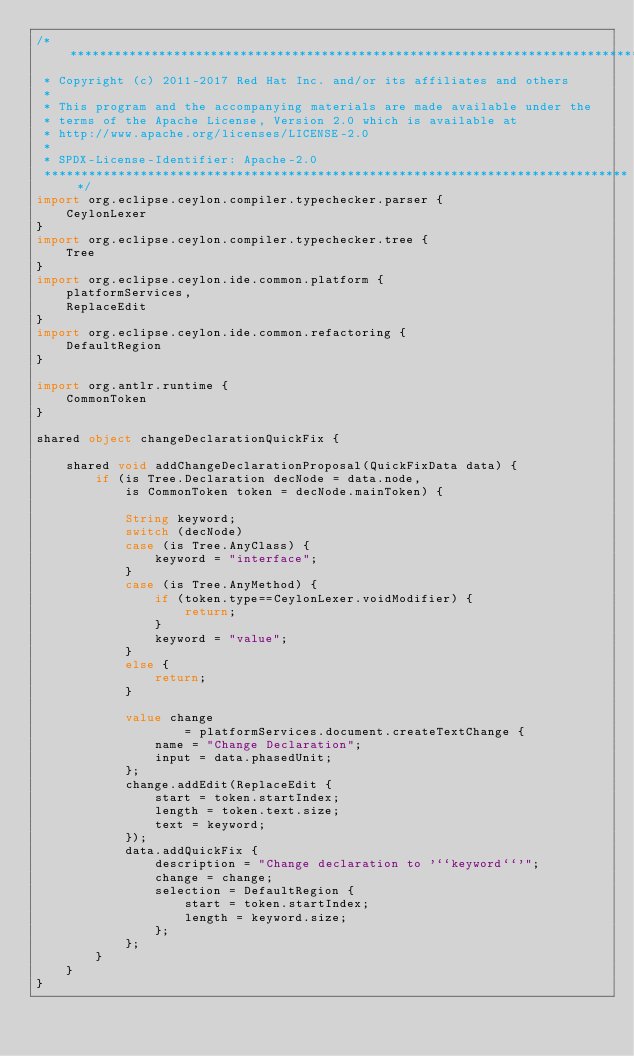Convert code to text. <code><loc_0><loc_0><loc_500><loc_500><_Ceylon_>/********************************************************************************
 * Copyright (c) 2011-2017 Red Hat Inc. and/or its affiliates and others
 *
 * This program and the accompanying materials are made available under the 
 * terms of the Apache License, Version 2.0 which is available at
 * http://www.apache.org/licenses/LICENSE-2.0
 *
 * SPDX-License-Identifier: Apache-2.0 
 ********************************************************************************/
import org.eclipse.ceylon.compiler.typechecker.parser {
    CeylonLexer
}
import org.eclipse.ceylon.compiler.typechecker.tree {
    Tree
}
import org.eclipse.ceylon.ide.common.platform {
    platformServices,
    ReplaceEdit
}
import org.eclipse.ceylon.ide.common.refactoring {
    DefaultRegion
}

import org.antlr.runtime {
    CommonToken
}

shared object changeDeclarationQuickFix {

    shared void addChangeDeclarationProposal(QuickFixData data) {
        if (is Tree.Declaration decNode = data.node,
            is CommonToken token = decNode.mainToken) {

            String keyword;
            switch (decNode)
            case (is Tree.AnyClass) {
                keyword = "interface";
            }
            case (is Tree.AnyMethod) {
                if (token.type==CeylonLexer.voidModifier) {
                    return;
                }
                keyword = "value";
            }
            else {
                return;
            }
                        
            value change 
                    = platformServices.document.createTextChange {
                name = "Change Declaration";
                input = data.phasedUnit;
            };
            change.addEdit(ReplaceEdit {
                start = token.startIndex;
                length = token.text.size;
                text = keyword;
            });
            data.addQuickFix {
                description = "Change declaration to '``keyword``'";
                change = change;
                selection = DefaultRegion {
                    start = token.startIndex;
                    length = keyword.size;
                };
            };
        }
    }
}
</code> 